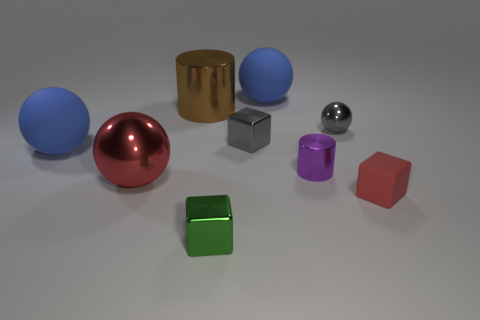Add 1 small blue metallic objects. How many objects exist? 10 Subtract all blocks. How many objects are left? 6 Subtract 1 gray balls. How many objects are left? 8 Subtract all tiny red rubber spheres. Subtract all big red objects. How many objects are left? 8 Add 2 red blocks. How many red blocks are left? 3 Add 6 large blue matte balls. How many large blue matte balls exist? 8 